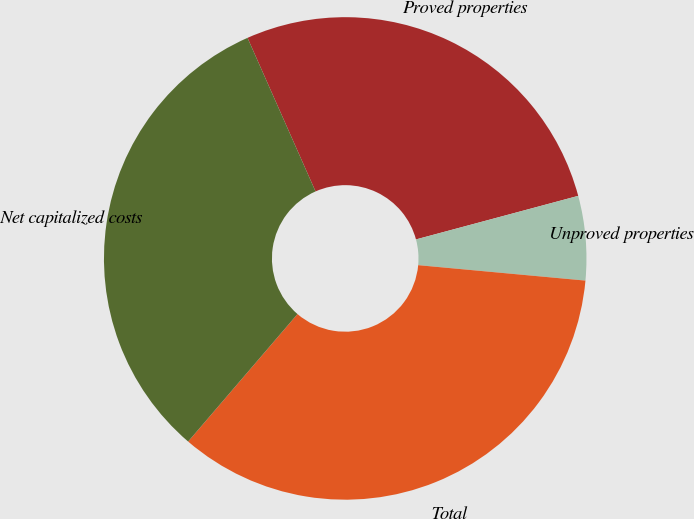Convert chart to OTSL. <chart><loc_0><loc_0><loc_500><loc_500><pie_chart><fcel>Proved properties<fcel>Unproved properties<fcel>Total<fcel>Net capitalized costs<nl><fcel>27.46%<fcel>5.64%<fcel>34.82%<fcel>32.08%<nl></chart> 